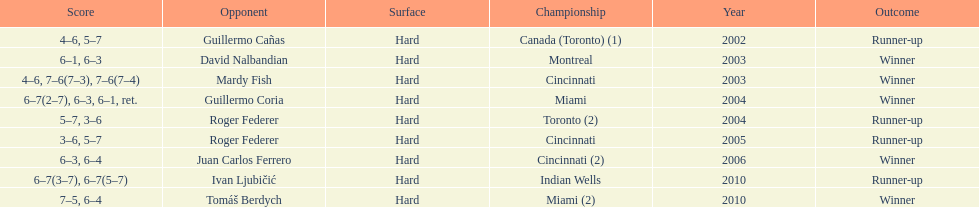How many championship competitions were held in toronto or montreal? 3. 